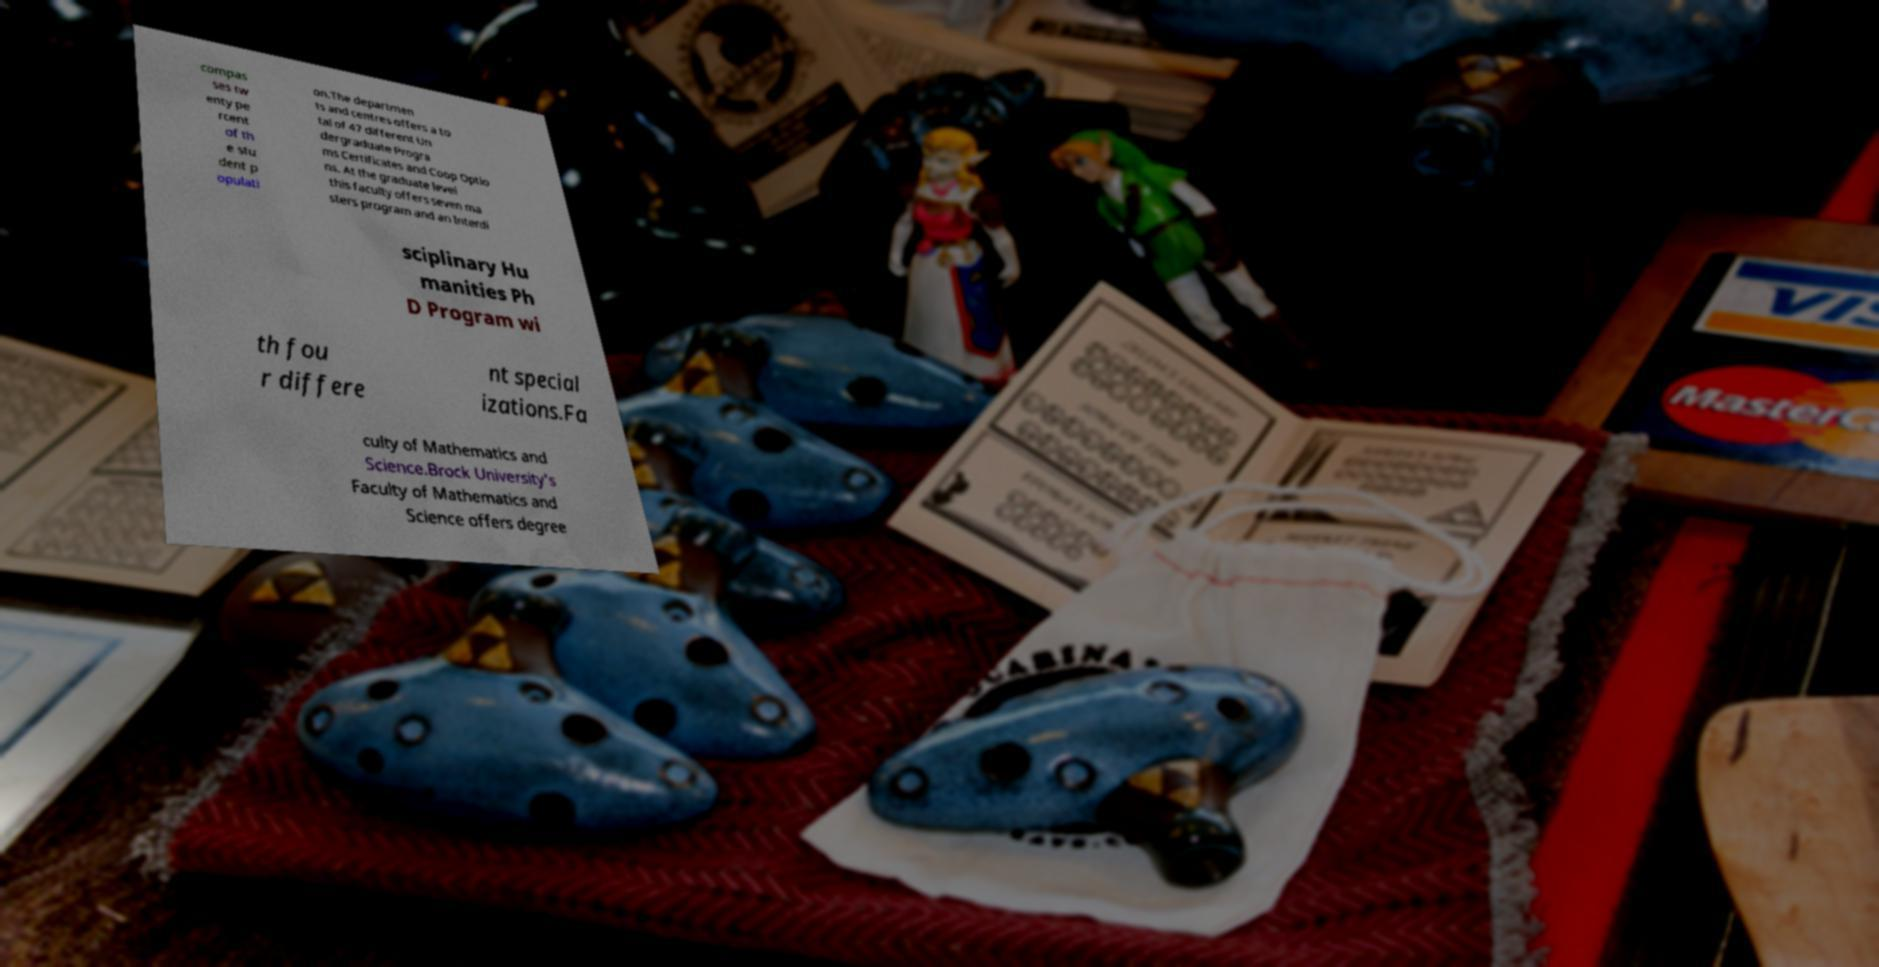For documentation purposes, I need the text within this image transcribed. Could you provide that? compas ses tw enty pe rcent of th e stu dent p opulati on.The departmen ts and centres offers a to tal of 47 different Un dergraduate Progra ms Certificates and Coop Optio ns. At the graduate level this faculty offers seven ma sters program and an Interdi sciplinary Hu manities Ph D Program wi th fou r differe nt special izations.Fa culty of Mathematics and Science.Brock University's Faculty of Mathematics and Science offers degree 